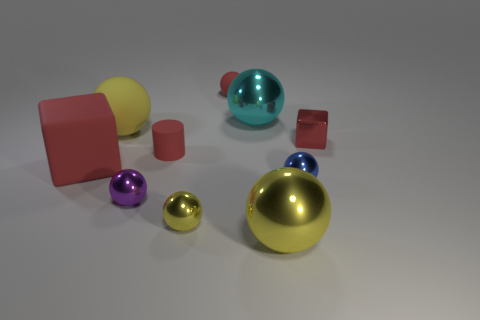There is a tiny thing that is right of the cyan metallic object and in front of the tiny red metallic block; what is its color?
Your response must be concise. Blue. How many big spheres are the same color as the rubber block?
Make the answer very short. 0. How many balls are either big yellow rubber things or purple metal things?
Ensure brevity in your answer.  2. What color is the matte cylinder that is the same size as the red sphere?
Offer a very short reply. Red. There is a shiny object behind the yellow thing on the left side of the cylinder; are there any tiny balls in front of it?
Ensure brevity in your answer.  Yes. What is the size of the yellow rubber thing?
Keep it short and to the point. Large. How many objects are cyan things or large green metallic cylinders?
Give a very brief answer. 1. There is a large ball that is the same material as the tiny red sphere; what color is it?
Offer a very short reply. Yellow. There is a small object that is on the right side of the blue object; is its shape the same as the large red matte thing?
Give a very brief answer. Yes. How many things are cubes left of the small red metal object or red things behind the cyan shiny ball?
Your response must be concise. 2. 